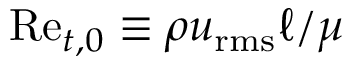<formula> <loc_0><loc_0><loc_500><loc_500>R e _ { t , 0 } \equiv \rho u _ { r m s } \ell / \mu</formula> 